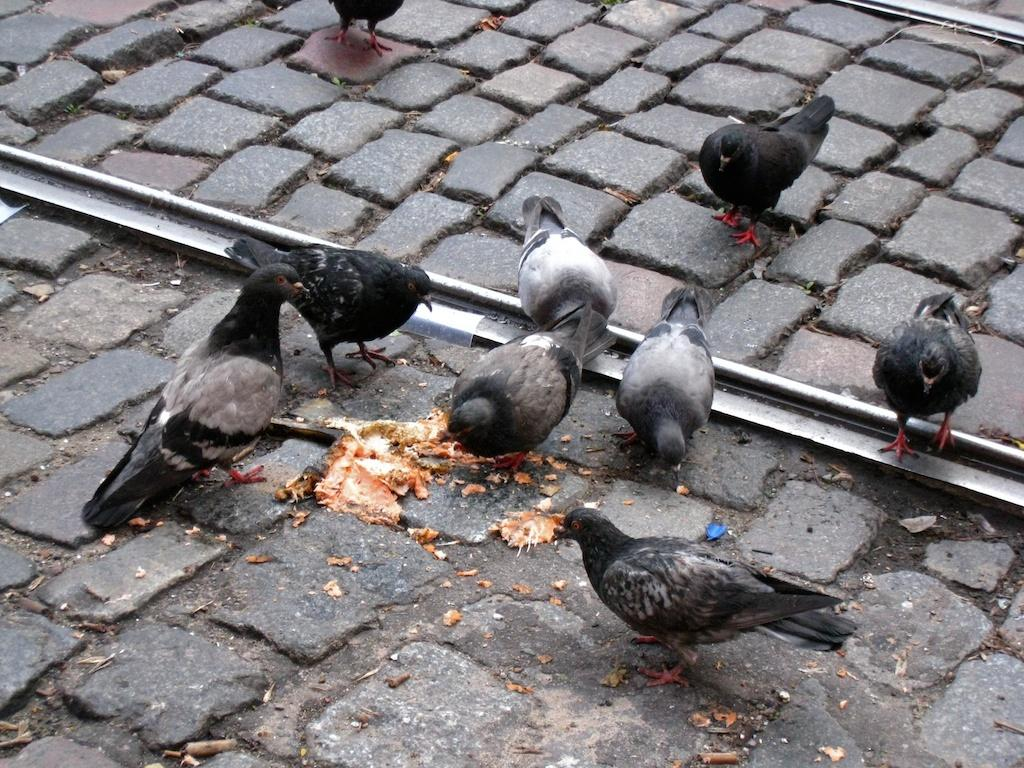What animals can be seen on the road in the image? There are pigeons on the road in the image. What else is present on the road in the image? There is a food item on the road in the image. What type of infrastructure is visible in the image? There is a railway track in the image. How does the street affect the pigeons' ability to breathe in the image? There is no street present in the image, only a railway track. Additionally, pigeons do not breathe through streets, so this question is not relevant to the image. 